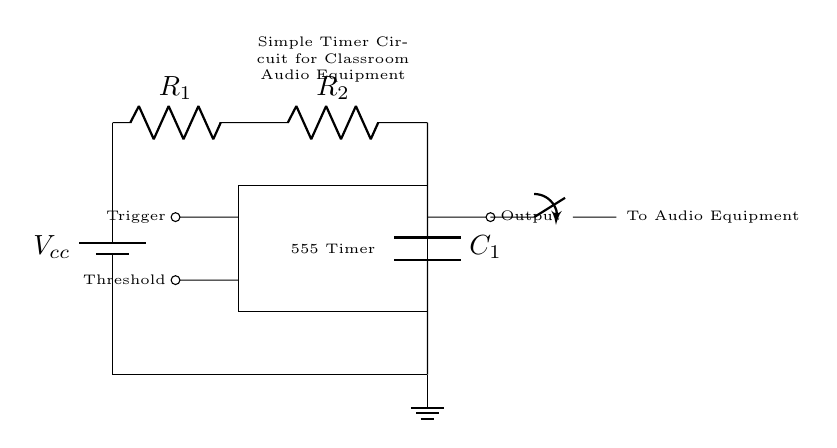What is the main component used in this circuit? The main component is the 555 Timer, which is a versatile integrated circuit used for generating precise timing delays. It can operate in different modes, including monostable and astable configurations. The diagram shows the 555 Timer prominently in the center.
Answer: 555 Timer What is the purpose of the resistors R1 and R2 in this circuit? Resistors R1 and R2 are used to set the timing intervals for the 555 Timer. They, along with the capacitor, determine the charge and discharge times which affect the output timing period when controlling the audio equipment.
Answer: Timing What is the role of capacitor C1 in this circuit? Capacitor C1 works with resistors R1 and R2 to dictate the timing characteristics of the circuit. It stores electrical energy and its charging and discharging through the resistors defines the timing cycle for the output generated by the 555 Timer.
Answer: Timing control How many outputs does the 555 Timer have in this circuit? The 555 Timer has one output pin in this configuration and sends a signal to the connected audio equipment when triggered. The output is shown on the right side of the 555 Timer in the diagram.
Answer: One What happens when the trigger input is activated? When the trigger input is activated, it starts the timing cycle, which causes the output to change state (on/off), thus controlling the connected audio equipment for a specific duration determined by the resistor and capacitor values.
Answer: Output activated What type of switch is used to control the audio equipment? A closing switch is used, which allows the path for current to flow to the audio equipment when closed. It enables the control of audio equipment based on the timing of the 555 Timer output.
Answer: Closing switch 